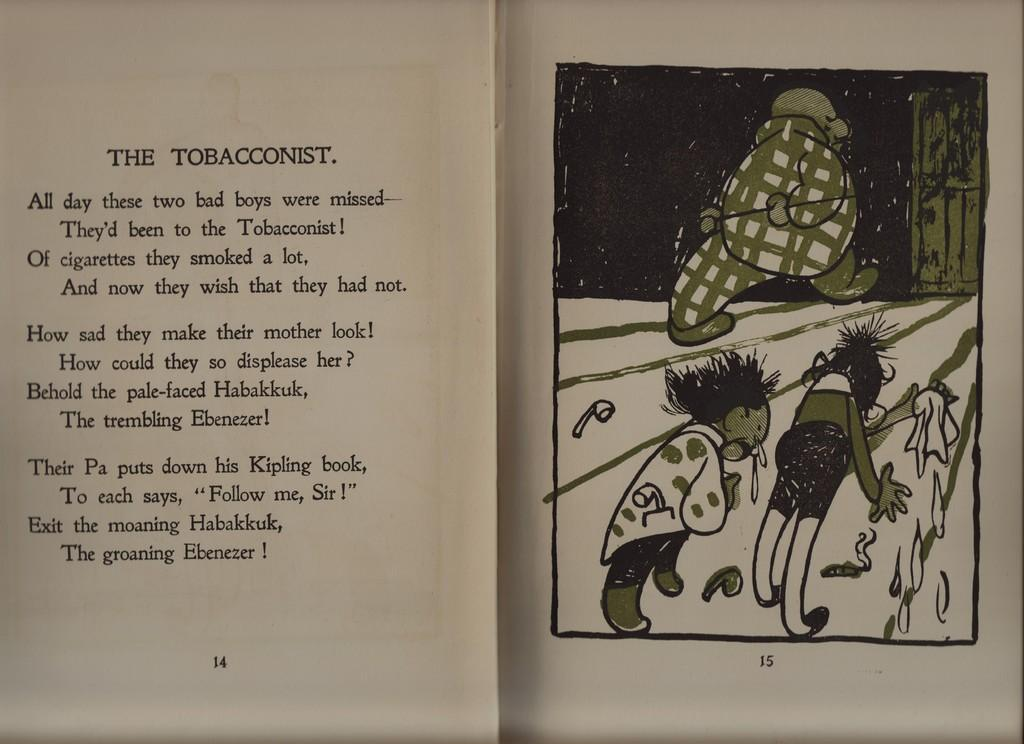Provide a one-sentence caption for the provided image. A book opened up with the story title, The Tobacconist on the left page and an image on the right page. 